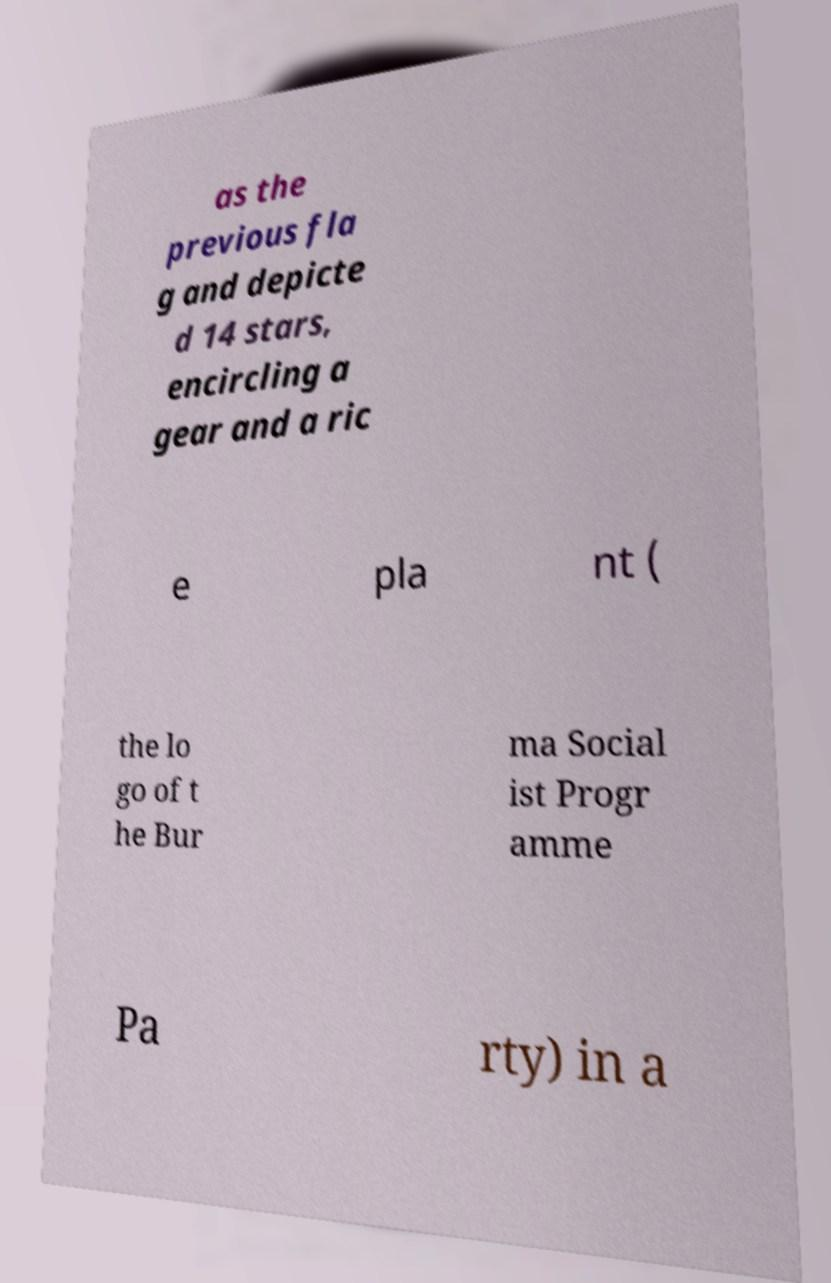What messages or text are displayed in this image? I need them in a readable, typed format. as the previous fla g and depicte d 14 stars, encircling a gear and a ric e pla nt ( the lo go of t he Bur ma Social ist Progr amme Pa rty) in a 